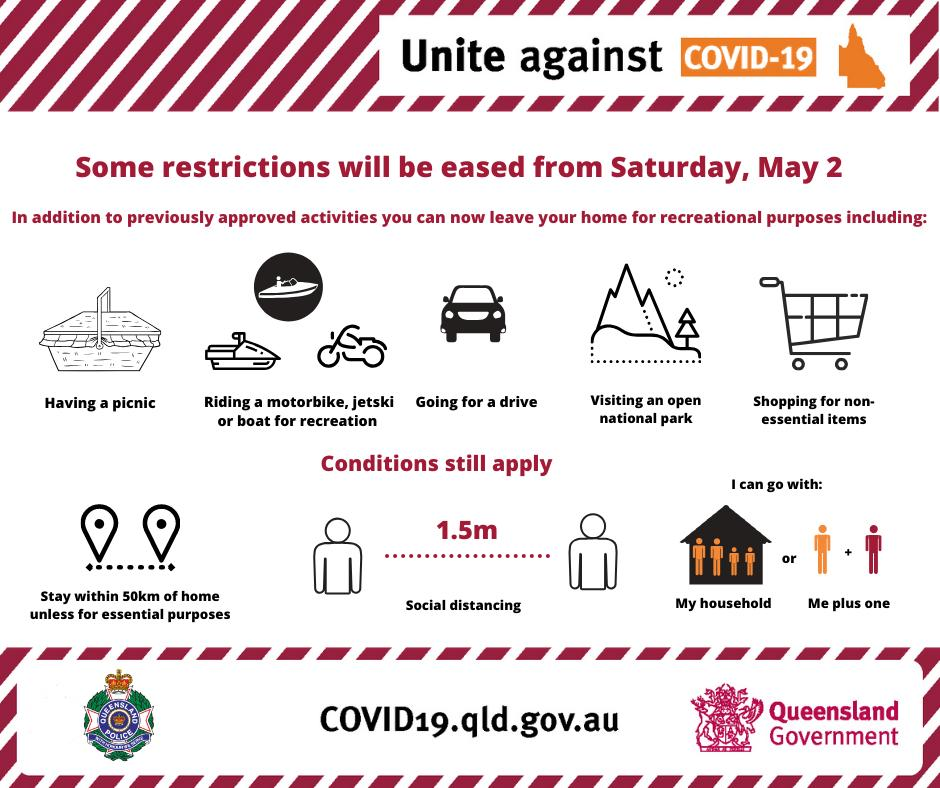Point out several critical features in this image. There are still three conditions that remain in effect. This infographic contains 5 recreational purposes. 